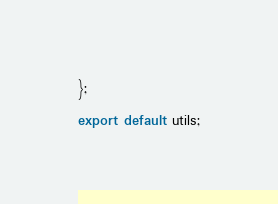<code> <loc_0><loc_0><loc_500><loc_500><_JavaScript_>};

export default utils;
</code> 